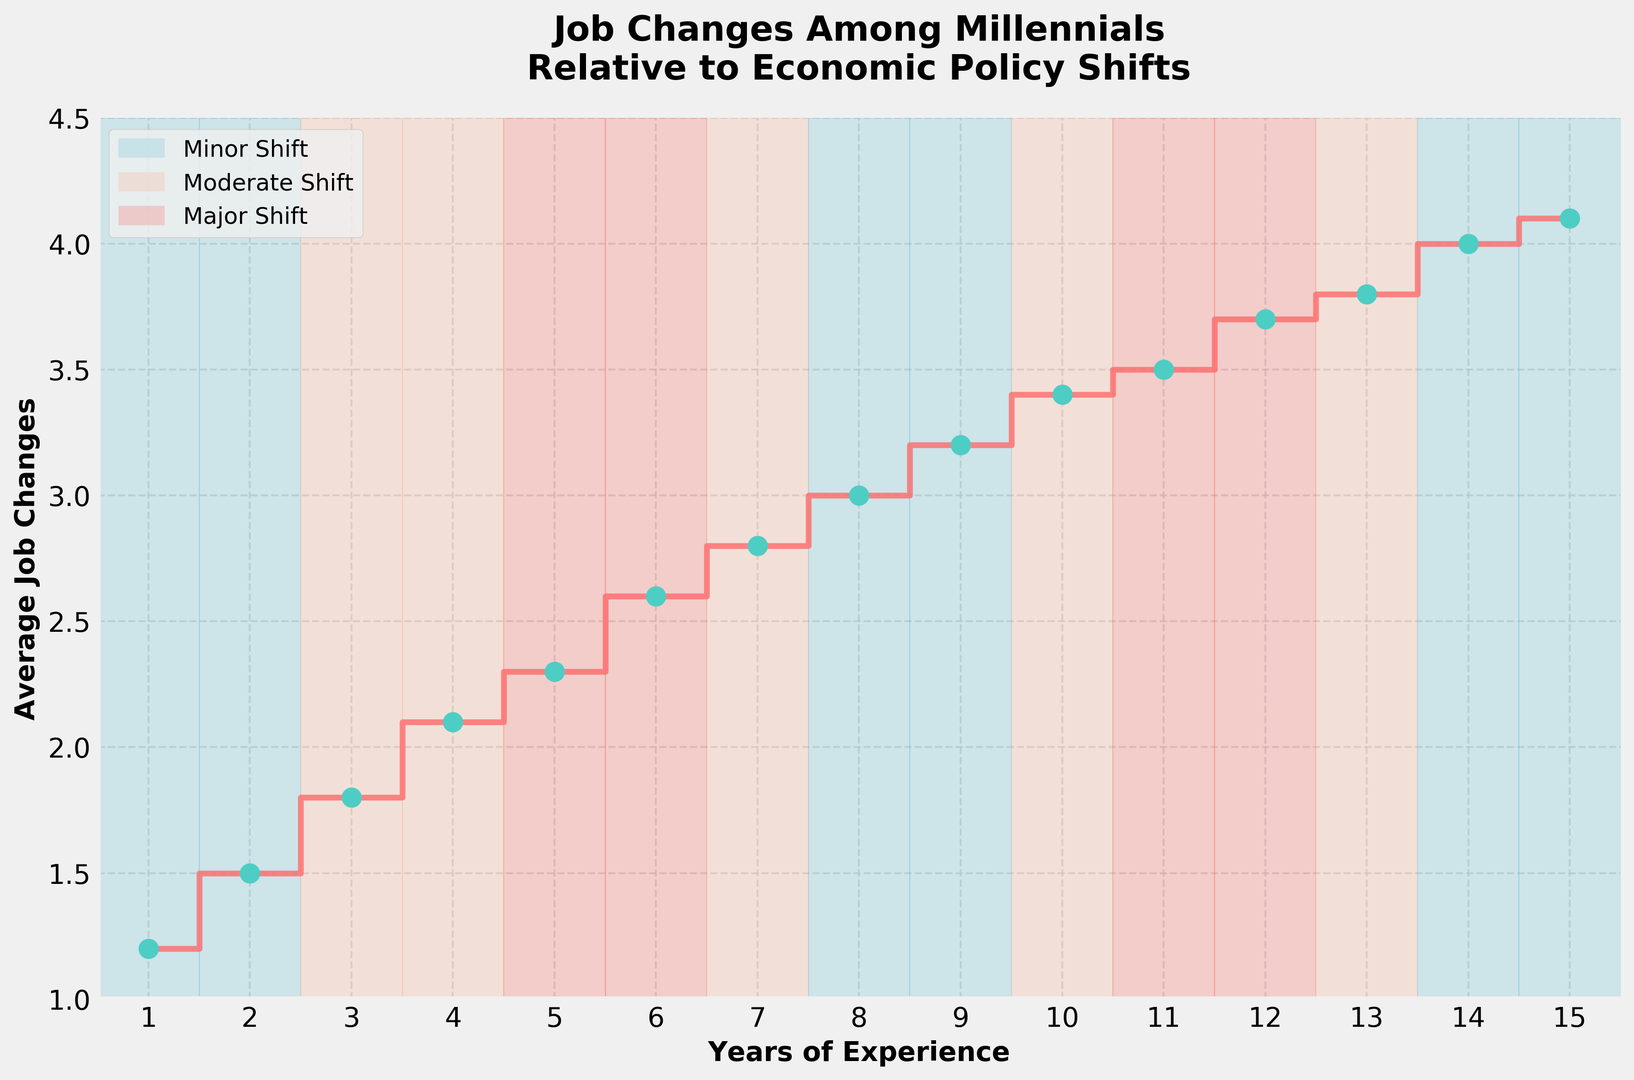What is the average number of job changes for someone with 5 years of experience? The plot shows that the average number of job changes for someone with 5 years of experience is marked at 2.3.
Answer: 2.3 Which economic policy shift has the most frequent occurrence and during which years does it span? By observing the color coding in the plot, the "Minor Shift" (blue) appears most frequently, occurring during the years 1-2, 8-9, and 14-15.
Answer: Minor Shift (years 1-2, 8-9, 14-15) During which economic policy shift do millennials with 3 years of experience have an average of 1.8 job changes? For 3 years of experience, the average job changes is 1.8, which falls under the "Moderate" economic policy shift (orange).
Answer: Moderate Shift How many more average job changes do millennials with 6 years of experience have compared to those with 3 years of experience? At 6 years, the average job changes is 2.6. At 3 years, it's 1.8. The difference is 2.6 - 1.8 = 0.8.
Answer: 0.8 Does the average number of job changes increase or decrease with major economic policy shifts? Observing the steps and economic policy spans, during major shifts (red), the average number of job changes either increases or remains same (e.g., from 2.3 to 3.7 between years 5-6 and 11-12).
Answer: Increase Between which years does the average number of job changes stay the same? And which economic policy shift occurs during these years? From year 10 to 11 the average job changes remains constant at 3.4 to 3.5 under "Moderate Shift" (orange).
Answer: Years 10-11, Moderate Shift How does the average number of job changes for someone with 1 year of experience compare to someone with 15 years of experience? At 1 year of experience, the average is 1.2 job changes. At 15 years, it is 4.1 job changes. Thus, the job changes increase with experience.
Answer: Increase What is the highest and lowest number of average job changes shown in the data? The lowest average job changes are 1.2 (at 1 year) and the highest is 4.1 (at 15 years).
Answer: Lowest: 1.2, Highest: 4.1 What color is used to represent major economic policy shifts, and which years does it span? Major economic policy shifts are represented with red color and span during the years 5-6 and 11-12.
Answer: Red, Years 5-6, 11-12 Identify the years where the average number of job changes crosses 3 job changes, and determine the corresponding economic policy shifts during those years. The average job changes cross 3 at year 8 and onwards. The corresponding economic policy shifts are Minor (years 8-9), Moderate (year 10), Major (years 11-12), and Minor (years 14-15).
Answer: Years 8-15, Minor, Moderate, Major 